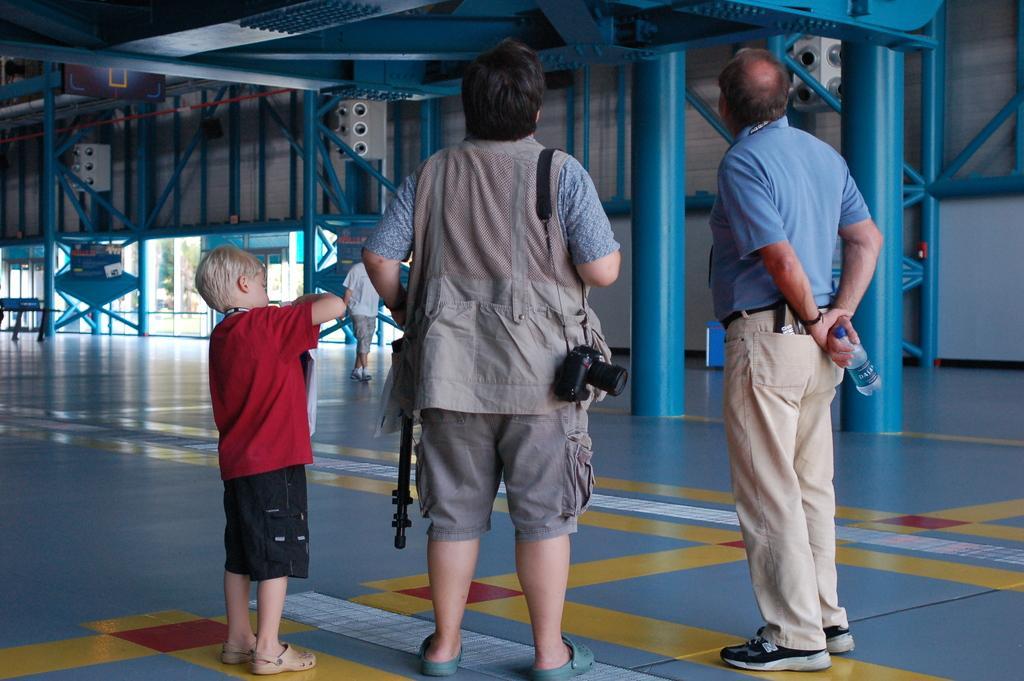Please provide a concise description of this image. In this picture I can see there is a woman, a bot and a man standing and they have a camera, there is a blue color poles and there is a door at the right side backdrop. 